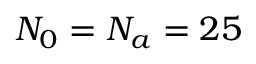Convert formula to latex. <formula><loc_0><loc_0><loc_500><loc_500>N _ { 0 } = N _ { a } = 2 5</formula> 